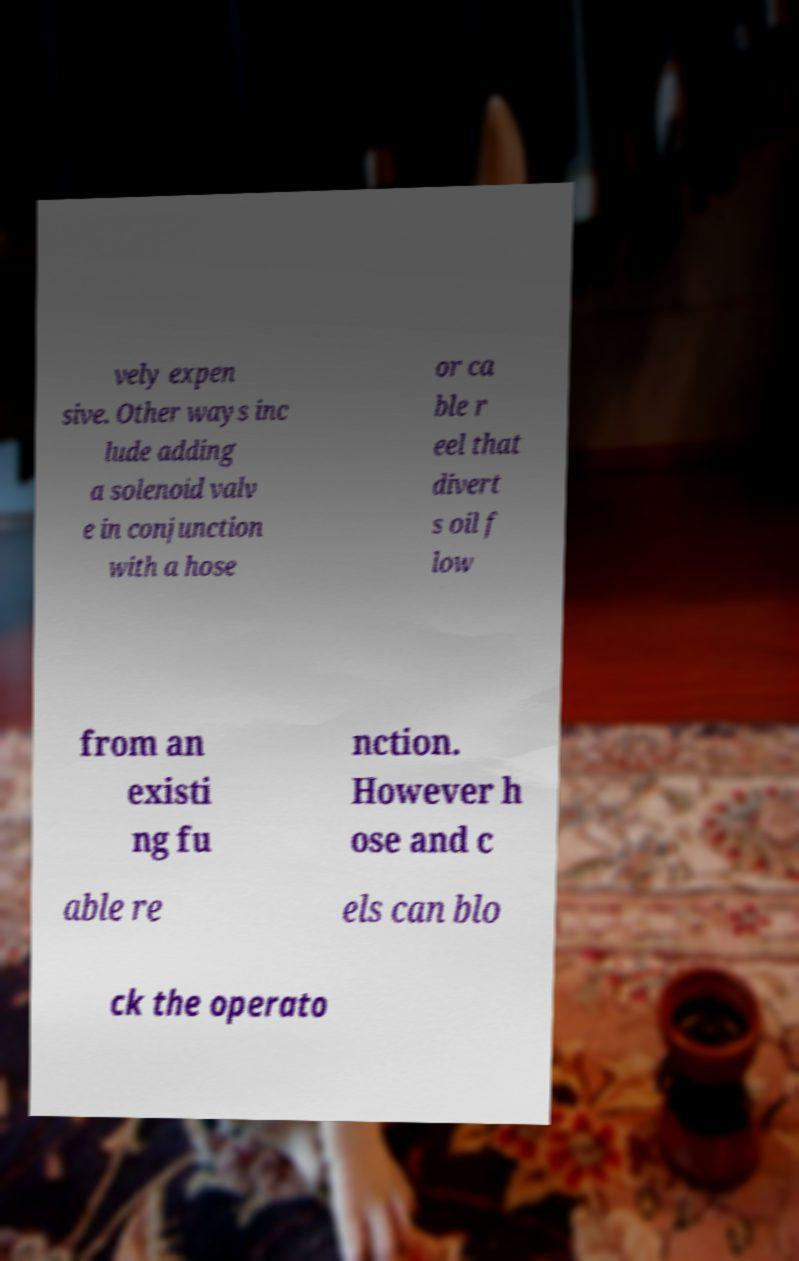There's text embedded in this image that I need extracted. Can you transcribe it verbatim? vely expen sive. Other ways inc lude adding a solenoid valv e in conjunction with a hose or ca ble r eel that divert s oil f low from an existi ng fu nction. However h ose and c able re els can blo ck the operato 